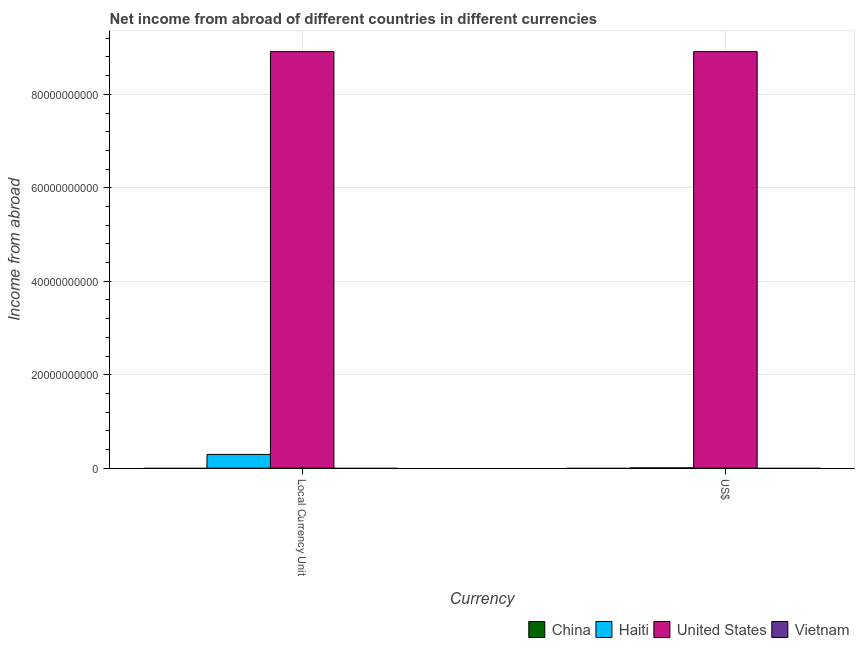How many groups of bars are there?
Your answer should be compact. 2. Are the number of bars on each tick of the X-axis equal?
Your answer should be very brief. Yes. How many bars are there on the 2nd tick from the left?
Offer a terse response. 2. What is the label of the 2nd group of bars from the left?
Provide a succinct answer. US$. Across all countries, what is the maximum income from abroad in us$?
Offer a very short reply. 8.91e+1. In which country was the income from abroad in constant 2005 us$ maximum?
Keep it short and to the point. United States. What is the total income from abroad in us$ in the graph?
Provide a short and direct response. 8.92e+1. What is the difference between the income from abroad in us$ in Haiti and that in United States?
Make the answer very short. -8.91e+1. What is the difference between the income from abroad in us$ in China and the income from abroad in constant 2005 us$ in Vietnam?
Provide a short and direct response. 0. What is the average income from abroad in constant 2005 us$ per country?
Your answer should be compact. 2.30e+1. What is the difference between the income from abroad in constant 2005 us$ and income from abroad in us$ in Haiti?
Give a very brief answer. 2.87e+09. In how many countries, is the income from abroad in constant 2005 us$ greater than the average income from abroad in constant 2005 us$ taken over all countries?
Your response must be concise. 1. How many countries are there in the graph?
Give a very brief answer. 4. What is the difference between two consecutive major ticks on the Y-axis?
Provide a succinct answer. 2.00e+1. Are the values on the major ticks of Y-axis written in scientific E-notation?
Keep it short and to the point. No. Does the graph contain any zero values?
Your answer should be compact. Yes. Does the graph contain grids?
Give a very brief answer. Yes. What is the title of the graph?
Offer a terse response. Net income from abroad of different countries in different currencies. Does "Bermuda" appear as one of the legend labels in the graph?
Offer a very short reply. No. What is the label or title of the X-axis?
Provide a short and direct response. Currency. What is the label or title of the Y-axis?
Your response must be concise. Income from abroad. What is the Income from abroad in Haiti in Local Currency Unit?
Offer a terse response. 2.95e+09. What is the Income from abroad in United States in Local Currency Unit?
Offer a terse response. 8.91e+1. What is the Income from abroad in Vietnam in Local Currency Unit?
Make the answer very short. 0. What is the Income from abroad in China in US$?
Offer a terse response. 0. What is the Income from abroad in Haiti in US$?
Offer a terse response. 7.43e+07. What is the Income from abroad of United States in US$?
Offer a terse response. 8.91e+1. What is the Income from abroad in Vietnam in US$?
Offer a very short reply. 0. Across all Currency, what is the maximum Income from abroad of Haiti?
Your answer should be very brief. 2.95e+09. Across all Currency, what is the maximum Income from abroad of United States?
Your answer should be very brief. 8.91e+1. Across all Currency, what is the minimum Income from abroad in Haiti?
Make the answer very short. 7.43e+07. Across all Currency, what is the minimum Income from abroad in United States?
Offer a terse response. 8.91e+1. What is the total Income from abroad in Haiti in the graph?
Provide a succinct answer. 3.02e+09. What is the total Income from abroad of United States in the graph?
Give a very brief answer. 1.78e+11. What is the total Income from abroad in Vietnam in the graph?
Give a very brief answer. 0. What is the difference between the Income from abroad in Haiti in Local Currency Unit and that in US$?
Provide a succinct answer. 2.87e+09. What is the difference between the Income from abroad in Haiti in Local Currency Unit and the Income from abroad in United States in US$?
Ensure brevity in your answer.  -8.62e+1. What is the average Income from abroad in Haiti per Currency?
Offer a terse response. 1.51e+09. What is the average Income from abroad of United States per Currency?
Provide a short and direct response. 8.91e+1. What is the difference between the Income from abroad of Haiti and Income from abroad of United States in Local Currency Unit?
Your response must be concise. -8.62e+1. What is the difference between the Income from abroad in Haiti and Income from abroad in United States in US$?
Your answer should be compact. -8.91e+1. What is the ratio of the Income from abroad in Haiti in Local Currency Unit to that in US$?
Offer a terse response. 39.68. What is the difference between the highest and the second highest Income from abroad of Haiti?
Your response must be concise. 2.87e+09. What is the difference between the highest and the second highest Income from abroad of United States?
Your answer should be very brief. 0. What is the difference between the highest and the lowest Income from abroad in Haiti?
Provide a short and direct response. 2.87e+09. 